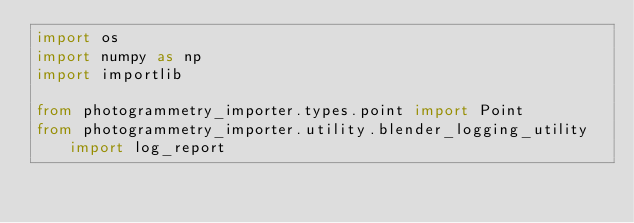Convert code to text. <code><loc_0><loc_0><loc_500><loc_500><_Python_>import os
import numpy as np
import importlib

from photogrammetry_importer.types.point import Point
from photogrammetry_importer.utility.blender_logging_utility import log_report</code> 